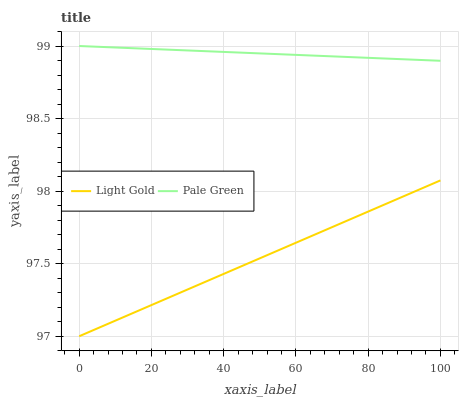Does Light Gold have the minimum area under the curve?
Answer yes or no. Yes. Does Pale Green have the maximum area under the curve?
Answer yes or no. Yes. Does Light Gold have the maximum area under the curve?
Answer yes or no. No. Is Pale Green the smoothest?
Answer yes or no. Yes. Is Light Gold the roughest?
Answer yes or no. Yes. Is Light Gold the smoothest?
Answer yes or no. No. Does Light Gold have the lowest value?
Answer yes or no. Yes. Does Pale Green have the highest value?
Answer yes or no. Yes. Does Light Gold have the highest value?
Answer yes or no. No. Is Light Gold less than Pale Green?
Answer yes or no. Yes. Is Pale Green greater than Light Gold?
Answer yes or no. Yes. Does Light Gold intersect Pale Green?
Answer yes or no. No. 